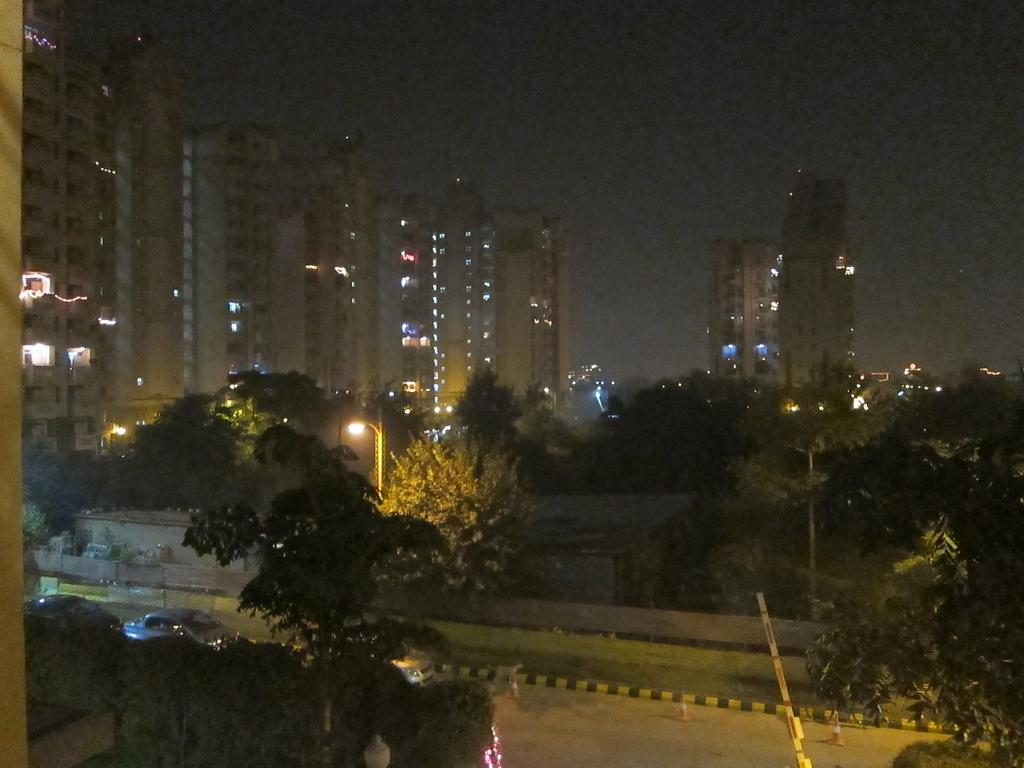What is the main feature of the image? There is a road in the image. What can be seen alongside the road? Trees, plants, and grass are visible along the road. Are there any structures or objects near the road? Light poles are present on either side of the road. What is visible in the background of the image? There are buildings and lights visible in the background. How would you describe the sky in the image? The sky is dark in the image. Can you see any nerves in the image? There are no nerves visible in the image; it features a road, trees, plants, grass, light poles, buildings, lights, and a dark sky. 